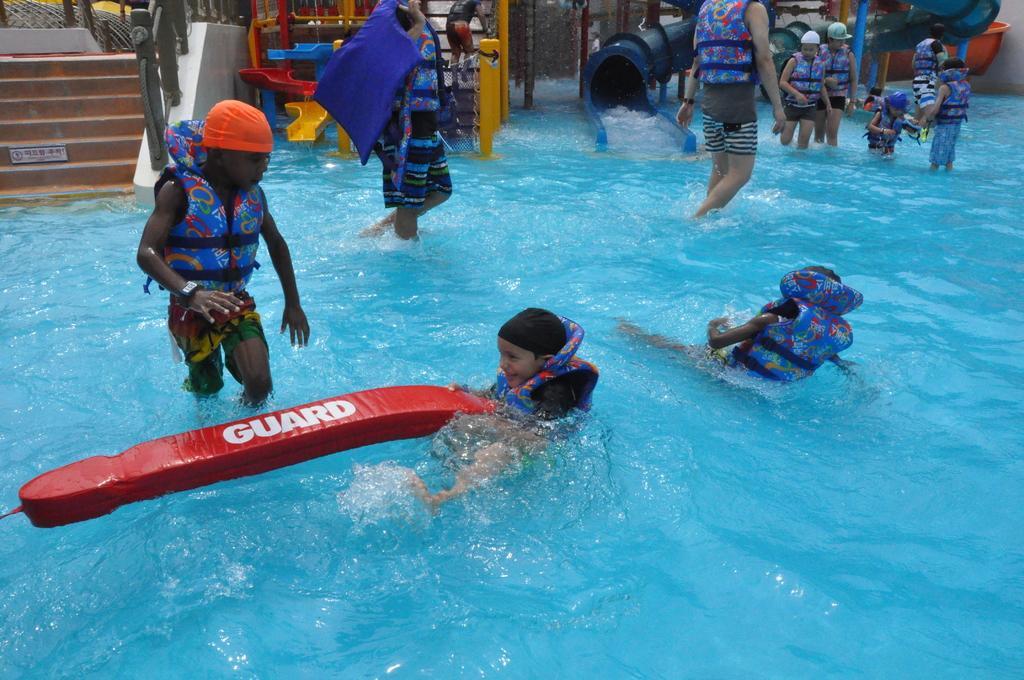In one or two sentences, can you explain what this image depicts? People are in water. These people wear life jackets. Background there are water slides and steps. This boy is holding a water object.  